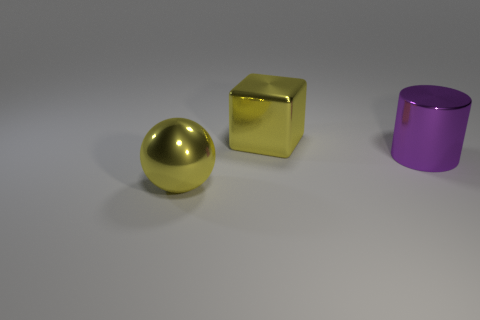There is a metal thing that is in front of the big shiny cylinder; is it the same color as the big cube?
Provide a short and direct response. Yes. There is a shiny object on the right side of the large cube; what is its size?
Provide a succinct answer. Large. There is a large object that is in front of the purple shiny object; does it have the same color as the large shiny object that is behind the large shiny cylinder?
Your response must be concise. Yes. What number of other objects are the same shape as the large purple object?
Provide a succinct answer. 0. Are there the same number of large metallic cylinders on the right side of the purple object and big yellow objects that are on the left side of the yellow cube?
Give a very brief answer. No. How many other things are there of the same size as the purple shiny cylinder?
Your response must be concise. 2. How many objects are either metallic things or things that are on the right side of the big yellow metal cube?
Keep it short and to the point. 3. Is the number of large purple metallic cylinders in front of the cylinder the same as the number of metallic objects?
Ensure brevity in your answer.  No. What shape is the yellow object that is the same material as the block?
Provide a short and direct response. Sphere. Are there any big spheres of the same color as the large metal block?
Keep it short and to the point. Yes. 